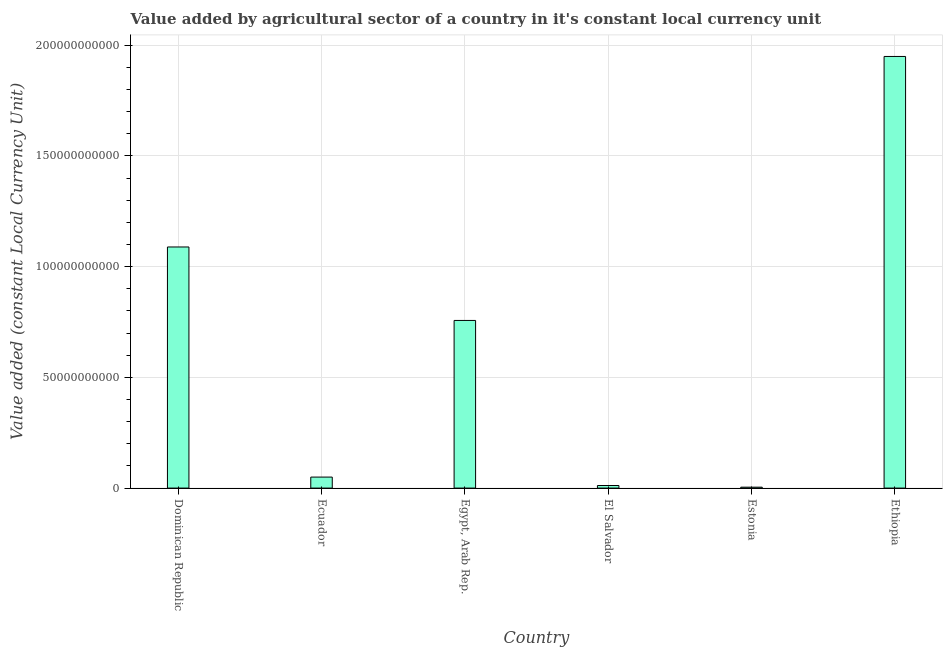Does the graph contain any zero values?
Keep it short and to the point. No. Does the graph contain grids?
Your answer should be compact. Yes. What is the title of the graph?
Give a very brief answer. Value added by agricultural sector of a country in it's constant local currency unit. What is the label or title of the Y-axis?
Your answer should be compact. Value added (constant Local Currency Unit). What is the value added by agriculture sector in Ethiopia?
Offer a terse response. 1.95e+11. Across all countries, what is the maximum value added by agriculture sector?
Provide a succinct answer. 1.95e+11. Across all countries, what is the minimum value added by agriculture sector?
Provide a short and direct response. 4.11e+08. In which country was the value added by agriculture sector maximum?
Keep it short and to the point. Ethiopia. In which country was the value added by agriculture sector minimum?
Provide a succinct answer. Estonia. What is the sum of the value added by agriculture sector?
Give a very brief answer. 3.86e+11. What is the difference between the value added by agriculture sector in Egypt, Arab Rep. and Ethiopia?
Make the answer very short. -1.19e+11. What is the average value added by agriculture sector per country?
Your response must be concise. 6.43e+1. What is the median value added by agriculture sector?
Your answer should be very brief. 4.03e+1. In how many countries, is the value added by agriculture sector greater than 140000000000 LCU?
Your answer should be compact. 1. What is the ratio of the value added by agriculture sector in El Salvador to that in Ethiopia?
Offer a very short reply. 0.01. Is the value added by agriculture sector in Dominican Republic less than that in El Salvador?
Your response must be concise. No. What is the difference between the highest and the second highest value added by agriculture sector?
Your answer should be compact. 8.60e+1. What is the difference between the highest and the lowest value added by agriculture sector?
Keep it short and to the point. 1.94e+11. Are all the bars in the graph horizontal?
Your response must be concise. No. What is the Value added (constant Local Currency Unit) in Dominican Republic?
Provide a succinct answer. 1.09e+11. What is the Value added (constant Local Currency Unit) in Ecuador?
Offer a terse response. 4.97e+09. What is the Value added (constant Local Currency Unit) of Egypt, Arab Rep.?
Offer a terse response. 7.57e+1. What is the Value added (constant Local Currency Unit) in El Salvador?
Provide a succinct answer. 1.17e+09. What is the Value added (constant Local Currency Unit) of Estonia?
Keep it short and to the point. 4.11e+08. What is the Value added (constant Local Currency Unit) in Ethiopia?
Offer a very short reply. 1.95e+11. What is the difference between the Value added (constant Local Currency Unit) in Dominican Republic and Ecuador?
Provide a succinct answer. 1.04e+11. What is the difference between the Value added (constant Local Currency Unit) in Dominican Republic and Egypt, Arab Rep.?
Your response must be concise. 3.32e+1. What is the difference between the Value added (constant Local Currency Unit) in Dominican Republic and El Salvador?
Your answer should be very brief. 1.08e+11. What is the difference between the Value added (constant Local Currency Unit) in Dominican Republic and Estonia?
Provide a short and direct response. 1.08e+11. What is the difference between the Value added (constant Local Currency Unit) in Dominican Republic and Ethiopia?
Keep it short and to the point. -8.60e+1. What is the difference between the Value added (constant Local Currency Unit) in Ecuador and Egypt, Arab Rep.?
Make the answer very short. -7.07e+1. What is the difference between the Value added (constant Local Currency Unit) in Ecuador and El Salvador?
Offer a terse response. 3.81e+09. What is the difference between the Value added (constant Local Currency Unit) in Ecuador and Estonia?
Your response must be concise. 4.56e+09. What is the difference between the Value added (constant Local Currency Unit) in Ecuador and Ethiopia?
Offer a very short reply. -1.90e+11. What is the difference between the Value added (constant Local Currency Unit) in Egypt, Arab Rep. and El Salvador?
Give a very brief answer. 7.45e+1. What is the difference between the Value added (constant Local Currency Unit) in Egypt, Arab Rep. and Estonia?
Offer a terse response. 7.53e+1. What is the difference between the Value added (constant Local Currency Unit) in Egypt, Arab Rep. and Ethiopia?
Offer a very short reply. -1.19e+11. What is the difference between the Value added (constant Local Currency Unit) in El Salvador and Estonia?
Your answer should be compact. 7.55e+08. What is the difference between the Value added (constant Local Currency Unit) in El Salvador and Ethiopia?
Offer a terse response. -1.94e+11. What is the difference between the Value added (constant Local Currency Unit) in Estonia and Ethiopia?
Your answer should be compact. -1.94e+11. What is the ratio of the Value added (constant Local Currency Unit) in Dominican Republic to that in Ecuador?
Provide a short and direct response. 21.9. What is the ratio of the Value added (constant Local Currency Unit) in Dominican Republic to that in Egypt, Arab Rep.?
Provide a short and direct response. 1.44. What is the ratio of the Value added (constant Local Currency Unit) in Dominican Republic to that in El Salvador?
Your answer should be compact. 93.4. What is the ratio of the Value added (constant Local Currency Unit) in Dominican Republic to that in Estonia?
Your answer should be very brief. 264.85. What is the ratio of the Value added (constant Local Currency Unit) in Dominican Republic to that in Ethiopia?
Offer a terse response. 0.56. What is the ratio of the Value added (constant Local Currency Unit) in Ecuador to that in Egypt, Arab Rep.?
Your answer should be compact. 0.07. What is the ratio of the Value added (constant Local Currency Unit) in Ecuador to that in El Salvador?
Offer a terse response. 4.26. What is the ratio of the Value added (constant Local Currency Unit) in Ecuador to that in Estonia?
Ensure brevity in your answer.  12.09. What is the ratio of the Value added (constant Local Currency Unit) in Ecuador to that in Ethiopia?
Make the answer very short. 0.03. What is the ratio of the Value added (constant Local Currency Unit) in Egypt, Arab Rep. to that in El Salvador?
Give a very brief answer. 64.94. What is the ratio of the Value added (constant Local Currency Unit) in Egypt, Arab Rep. to that in Estonia?
Your response must be concise. 184.16. What is the ratio of the Value added (constant Local Currency Unit) in Egypt, Arab Rep. to that in Ethiopia?
Your answer should be compact. 0.39. What is the ratio of the Value added (constant Local Currency Unit) in El Salvador to that in Estonia?
Ensure brevity in your answer.  2.84. What is the ratio of the Value added (constant Local Currency Unit) in El Salvador to that in Ethiopia?
Ensure brevity in your answer.  0.01. What is the ratio of the Value added (constant Local Currency Unit) in Estonia to that in Ethiopia?
Offer a very short reply. 0. 